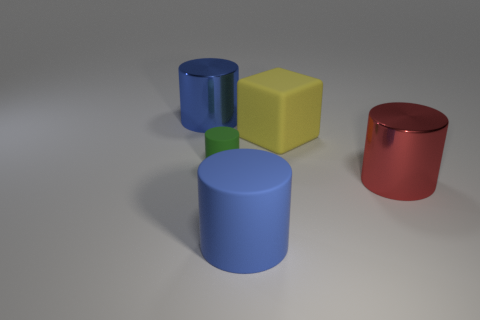Does the green cylinder that is in front of the yellow cube have the same material as the blue cylinder in front of the small green cylinder?
Offer a terse response. Yes. What is the size of the matte cylinder that is behind the large metal object in front of the yellow object?
Your answer should be compact. Small. Are there any small things of the same color as the large rubber cylinder?
Offer a terse response. No. There is a big thing left of the large blue matte cylinder; is it the same color as the matte cube that is on the right side of the small cylinder?
Provide a short and direct response. No. There is a small thing; what shape is it?
Your response must be concise. Cylinder. How many small green rubber cylinders are on the right side of the large yellow matte object?
Offer a terse response. 0. How many tiny cylinders are made of the same material as the large yellow thing?
Provide a succinct answer. 1. Is the material of the blue thing that is in front of the green cylinder the same as the big block?
Offer a terse response. Yes. Are any tiny matte cylinders visible?
Make the answer very short. Yes. There is a rubber thing that is behind the red cylinder and to the left of the big rubber cube; what is its size?
Your response must be concise. Small. 